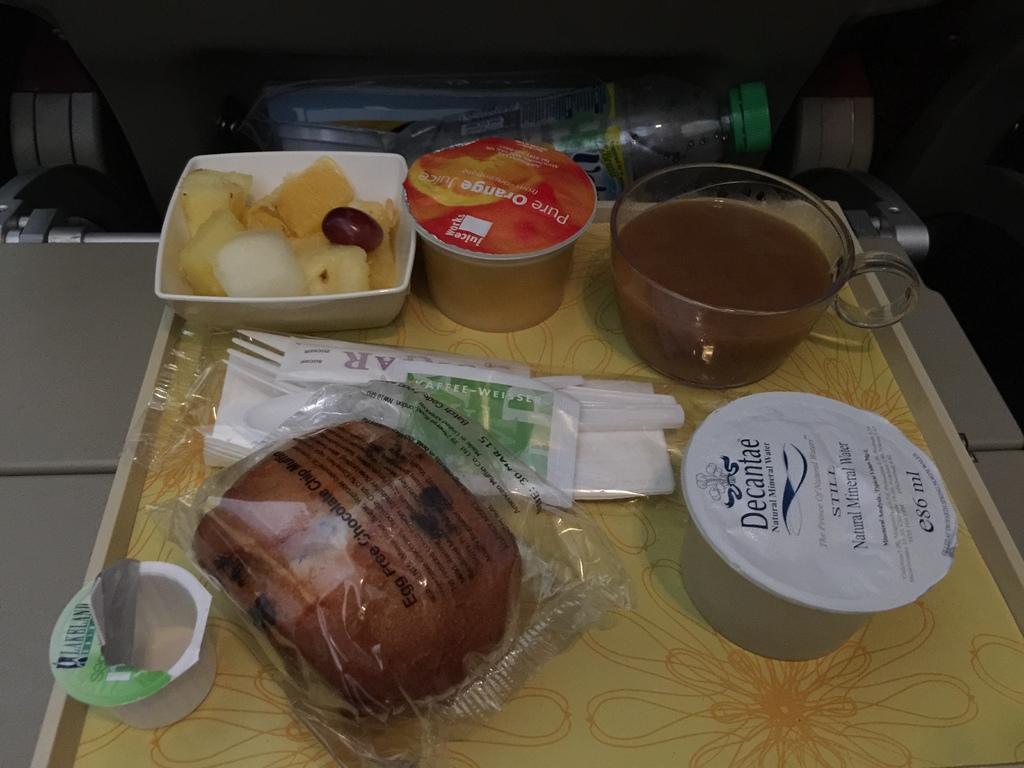How would you summarize this image in a sentence or two? In the picture there are some food items placed on a tray and behind the tray there are some waste items. 